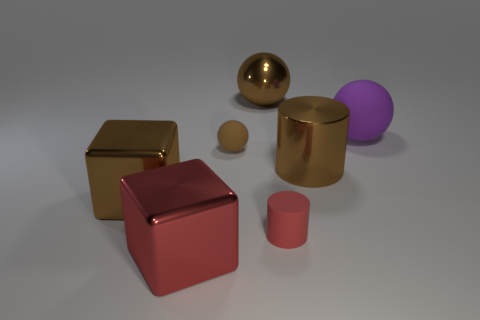How big is the brown metallic thing that is to the right of the large brown thing that is behind the brown matte sphere?
Offer a terse response. Large. What number of big things are either red metal blocks or purple balls?
Make the answer very short. 2. There is a metal cube right of the large shiny thing that is on the left side of the red object that is left of the big metallic sphere; what size is it?
Give a very brief answer. Large. Is there anything else that has the same color as the large rubber object?
Make the answer very short. No. The big brown thing that is behind the large brown metallic cylinder that is in front of the large brown object that is behind the purple sphere is made of what material?
Your answer should be very brief. Metal. Does the big purple object have the same shape as the brown rubber object?
Give a very brief answer. Yes. What number of brown things are both in front of the tiny brown rubber sphere and on the left side of the brown cylinder?
Provide a short and direct response. 1. What is the color of the ball that is on the right side of the big ball on the left side of the red matte cylinder?
Offer a terse response. Purple. Are there an equal number of small objects that are to the left of the big red cube and big yellow blocks?
Offer a terse response. Yes. There is a large brown shiny object that is behind the matte ball in front of the large purple rubber thing; how many small cylinders are in front of it?
Your answer should be compact. 1. 